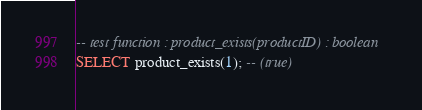<code> <loc_0><loc_0><loc_500><loc_500><_SQL_>-- test function : product_exists(productID) : boolean
SELECT product_exists(1); -- (true)</code> 